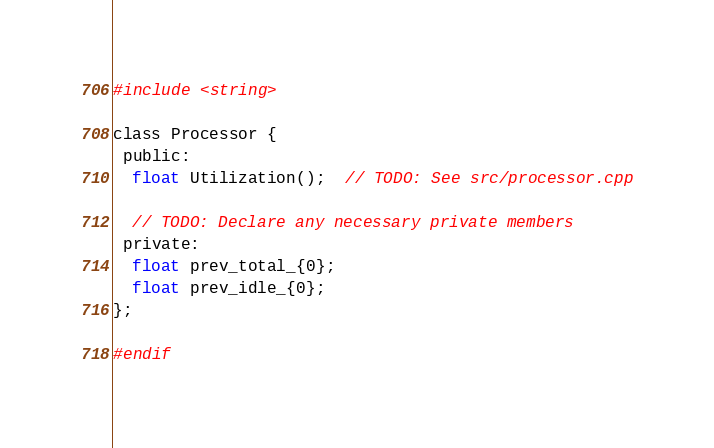Convert code to text. <code><loc_0><loc_0><loc_500><loc_500><_C_>#include <string>

class Processor {
 public:
  float Utilization();  // TODO: See src/processor.cpp

  // TODO: Declare any necessary private members
 private:
  float prev_total_{0};
  float prev_idle_{0};
};

#endif</code> 